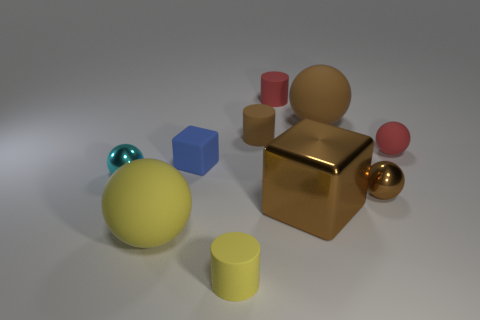Subtract all yellow spheres. How many spheres are left? 4 Subtract all small cyan balls. How many balls are left? 4 Subtract all cyan blocks. Subtract all brown balls. How many blocks are left? 2 Subtract all cylinders. How many objects are left? 7 Add 8 cyan rubber cubes. How many cyan rubber cubes exist? 8 Subtract 0 cyan blocks. How many objects are left? 10 Subtract all purple things. Subtract all small red rubber cylinders. How many objects are left? 9 Add 3 large balls. How many large balls are left? 5 